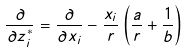<formula> <loc_0><loc_0><loc_500><loc_500>\frac { \partial } { \partial z _ { i } ^ { * } } = \frac { \partial } { \partial x _ { i } } - \frac { x _ { i } } { r } \left ( \frac { a } { r } + \frac { 1 } { b } \right )</formula> 